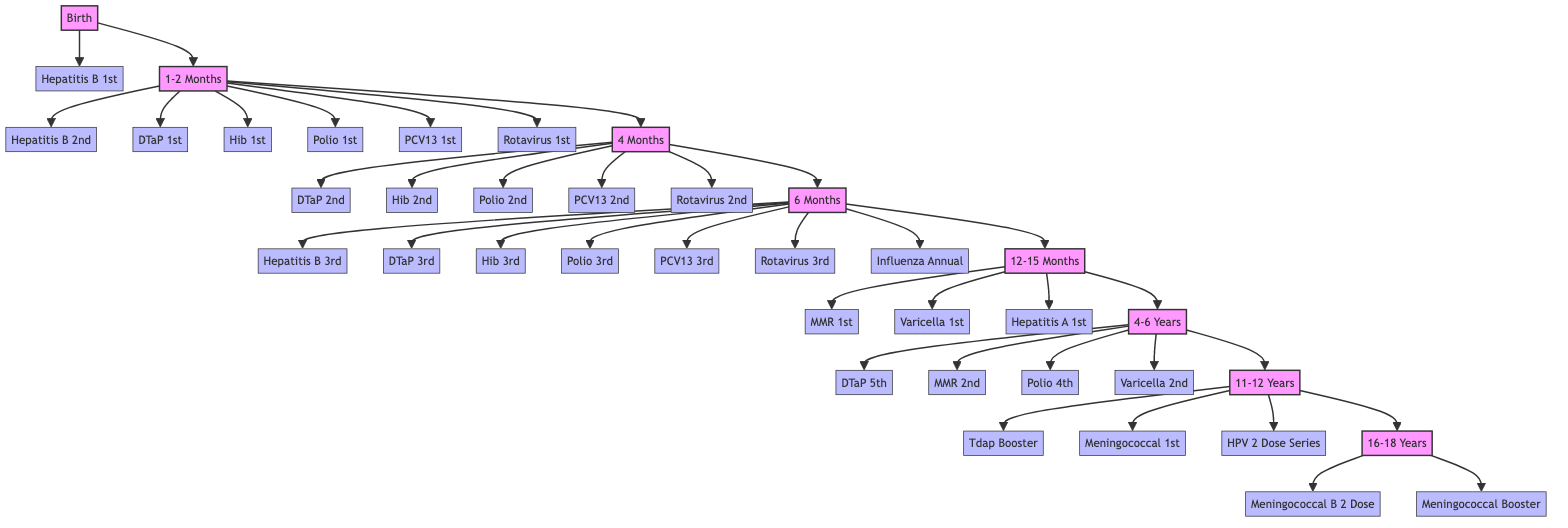What vaccinations are given at birth? The diagram shows that the vaccination given at birth is the Hepatitis B vaccine, specifically the 1st dose.
Answer: Hepatitis B 1st How many major age groups are there in the vaccination schedule? By counting the age groups listed in the diagram, we find there are 6 major age groups: Birth, 1-2 Months, 4 Months, 6 Months, 12-15 Months, 4-6 Years, 11-12 Years, and 16-18 Years.
Answer: 8 Which vaccine is administered in a 2 Dose Series between 11-12 years? The diagram indicates that the Human Papillomavirus (HPV) vaccine is given as a 2 Dose Series over 6-12 months for children aged 11-12 years.
Answer: HPV 2 Dose Series What is the relation between the 6 Months milestone and the 12-15 Months milestone? The diagram shows that after going through the 6 Months milestone, it directly connects to the 12-15 Months milestone, indicating that these are two successive stages in the vaccination timeline.
Answer: Successive stages How many vaccinations are scheduled during the 1-2 Months period? A review of the vaccination entries under the 1-2 Months milestone reveals that there are 6 vaccinations listed, specifically the Hepatitis B, DTaP, Hib, Polio, Pneumococcal, and Rotavirus vaccines.
Answer: 6 What are the two vaccines given as a booster for adolescents aged 16-18? According to the diagram, during the 16-18 years milestone, the vaccines given as boosters are the Meningococcal B and the Meningococcal (MenACWY) booster.
Answer: Meningococcal B, Meningococcal Booster Which milestone requires a booster dose for Tdap? The diagram shows that the Tdap vaccine, labeled as a booster, is scheduled for the 11-12 Years milestone.
Answer: 11-12 Years What is the vaccination given at 4-6 years for Polio? The diagram states that the Polio vaccine given during the 4-6 Years milestone is the 4th dose.
Answer: 4th Dose 